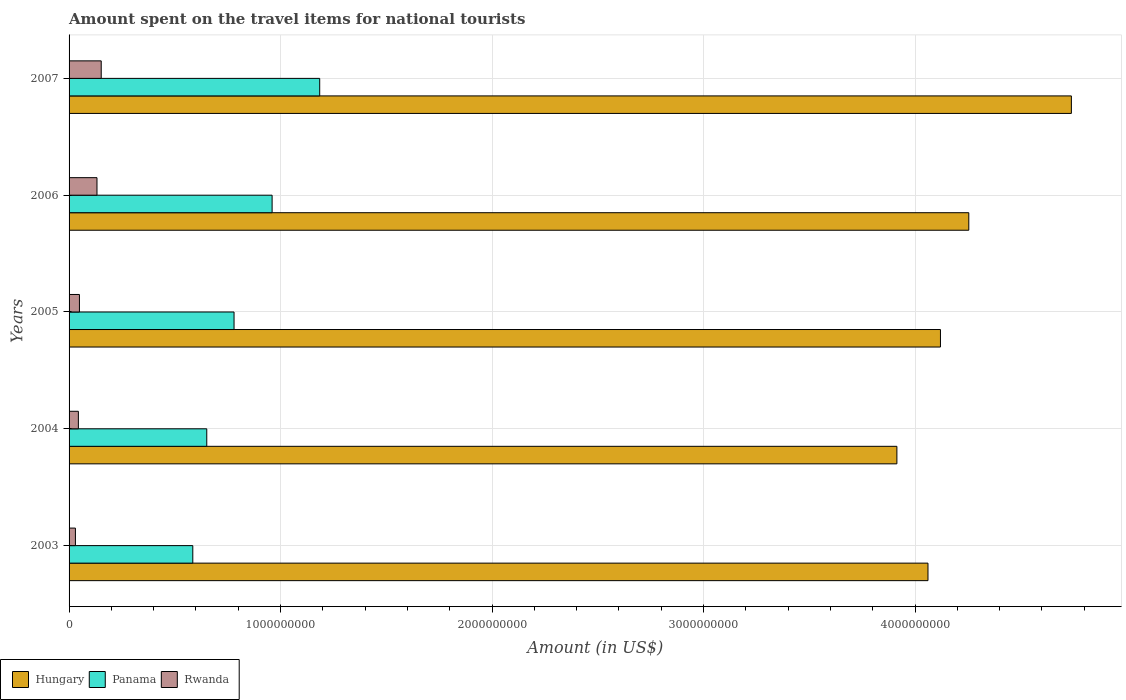How many different coloured bars are there?
Your response must be concise. 3. How many bars are there on the 4th tick from the top?
Your answer should be compact. 3. What is the label of the 3rd group of bars from the top?
Provide a succinct answer. 2005. In how many cases, is the number of bars for a given year not equal to the number of legend labels?
Ensure brevity in your answer.  0. What is the amount spent on the travel items for national tourists in Panama in 2003?
Your answer should be very brief. 5.85e+08. Across all years, what is the maximum amount spent on the travel items for national tourists in Rwanda?
Offer a very short reply. 1.52e+08. Across all years, what is the minimum amount spent on the travel items for national tourists in Hungary?
Ensure brevity in your answer.  3.91e+09. What is the total amount spent on the travel items for national tourists in Panama in the graph?
Your answer should be very brief. 4.16e+09. What is the difference between the amount spent on the travel items for national tourists in Panama in 2003 and that in 2006?
Your response must be concise. -3.75e+08. What is the difference between the amount spent on the travel items for national tourists in Rwanda in 2007 and the amount spent on the travel items for national tourists in Panama in 2003?
Make the answer very short. -4.33e+08. What is the average amount spent on the travel items for national tourists in Rwanda per year?
Offer a very short reply. 8.14e+07. In the year 2003, what is the difference between the amount spent on the travel items for national tourists in Rwanda and amount spent on the travel items for national tourists in Panama?
Make the answer very short. -5.55e+08. What is the ratio of the amount spent on the travel items for national tourists in Hungary in 2004 to that in 2007?
Offer a very short reply. 0.83. Is the amount spent on the travel items for national tourists in Hungary in 2005 less than that in 2006?
Your response must be concise. Yes. What is the difference between the highest and the second highest amount spent on the travel items for national tourists in Hungary?
Your answer should be compact. 4.85e+08. What is the difference between the highest and the lowest amount spent on the travel items for national tourists in Hungary?
Keep it short and to the point. 8.25e+08. What does the 3rd bar from the top in 2004 represents?
Offer a terse response. Hungary. What does the 1st bar from the bottom in 2006 represents?
Your response must be concise. Hungary. Does the graph contain grids?
Ensure brevity in your answer.  Yes. How many legend labels are there?
Ensure brevity in your answer.  3. How are the legend labels stacked?
Provide a short and direct response. Horizontal. What is the title of the graph?
Provide a succinct answer. Amount spent on the travel items for national tourists. Does "Latvia" appear as one of the legend labels in the graph?
Keep it short and to the point. No. What is the label or title of the X-axis?
Your response must be concise. Amount (in US$). What is the label or title of the Y-axis?
Ensure brevity in your answer.  Years. What is the Amount (in US$) in Hungary in 2003?
Your answer should be very brief. 4.06e+09. What is the Amount (in US$) in Panama in 2003?
Your answer should be very brief. 5.85e+08. What is the Amount (in US$) in Rwanda in 2003?
Your response must be concise. 3.00e+07. What is the Amount (in US$) of Hungary in 2004?
Offer a very short reply. 3.91e+09. What is the Amount (in US$) of Panama in 2004?
Offer a very short reply. 6.51e+08. What is the Amount (in US$) in Rwanda in 2004?
Offer a terse response. 4.40e+07. What is the Amount (in US$) in Hungary in 2005?
Your answer should be very brief. 4.12e+09. What is the Amount (in US$) in Panama in 2005?
Keep it short and to the point. 7.80e+08. What is the Amount (in US$) of Rwanda in 2005?
Your answer should be compact. 4.90e+07. What is the Amount (in US$) in Hungary in 2006?
Offer a terse response. 4.25e+09. What is the Amount (in US$) in Panama in 2006?
Offer a terse response. 9.60e+08. What is the Amount (in US$) in Rwanda in 2006?
Offer a very short reply. 1.32e+08. What is the Amount (in US$) in Hungary in 2007?
Provide a short and direct response. 4.74e+09. What is the Amount (in US$) in Panama in 2007?
Ensure brevity in your answer.  1.18e+09. What is the Amount (in US$) of Rwanda in 2007?
Your response must be concise. 1.52e+08. Across all years, what is the maximum Amount (in US$) in Hungary?
Your answer should be very brief. 4.74e+09. Across all years, what is the maximum Amount (in US$) in Panama?
Keep it short and to the point. 1.18e+09. Across all years, what is the maximum Amount (in US$) in Rwanda?
Ensure brevity in your answer.  1.52e+08. Across all years, what is the minimum Amount (in US$) in Hungary?
Ensure brevity in your answer.  3.91e+09. Across all years, what is the minimum Amount (in US$) of Panama?
Provide a short and direct response. 5.85e+08. Across all years, what is the minimum Amount (in US$) in Rwanda?
Your answer should be very brief. 3.00e+07. What is the total Amount (in US$) of Hungary in the graph?
Make the answer very short. 2.11e+1. What is the total Amount (in US$) of Panama in the graph?
Ensure brevity in your answer.  4.16e+09. What is the total Amount (in US$) of Rwanda in the graph?
Your response must be concise. 4.07e+08. What is the difference between the Amount (in US$) in Hungary in 2003 and that in 2004?
Ensure brevity in your answer.  1.47e+08. What is the difference between the Amount (in US$) in Panama in 2003 and that in 2004?
Your response must be concise. -6.60e+07. What is the difference between the Amount (in US$) in Rwanda in 2003 and that in 2004?
Your response must be concise. -1.40e+07. What is the difference between the Amount (in US$) in Hungary in 2003 and that in 2005?
Offer a terse response. -5.90e+07. What is the difference between the Amount (in US$) in Panama in 2003 and that in 2005?
Make the answer very short. -1.95e+08. What is the difference between the Amount (in US$) in Rwanda in 2003 and that in 2005?
Offer a very short reply. -1.90e+07. What is the difference between the Amount (in US$) in Hungary in 2003 and that in 2006?
Provide a succinct answer. -1.93e+08. What is the difference between the Amount (in US$) in Panama in 2003 and that in 2006?
Your response must be concise. -3.75e+08. What is the difference between the Amount (in US$) in Rwanda in 2003 and that in 2006?
Your answer should be very brief. -1.02e+08. What is the difference between the Amount (in US$) in Hungary in 2003 and that in 2007?
Keep it short and to the point. -6.78e+08. What is the difference between the Amount (in US$) in Panama in 2003 and that in 2007?
Keep it short and to the point. -6.00e+08. What is the difference between the Amount (in US$) of Rwanda in 2003 and that in 2007?
Give a very brief answer. -1.22e+08. What is the difference between the Amount (in US$) in Hungary in 2004 and that in 2005?
Offer a terse response. -2.06e+08. What is the difference between the Amount (in US$) in Panama in 2004 and that in 2005?
Make the answer very short. -1.29e+08. What is the difference between the Amount (in US$) of Rwanda in 2004 and that in 2005?
Your answer should be very brief. -5.00e+06. What is the difference between the Amount (in US$) in Hungary in 2004 and that in 2006?
Keep it short and to the point. -3.40e+08. What is the difference between the Amount (in US$) in Panama in 2004 and that in 2006?
Offer a very short reply. -3.09e+08. What is the difference between the Amount (in US$) in Rwanda in 2004 and that in 2006?
Provide a short and direct response. -8.80e+07. What is the difference between the Amount (in US$) of Hungary in 2004 and that in 2007?
Give a very brief answer. -8.25e+08. What is the difference between the Amount (in US$) of Panama in 2004 and that in 2007?
Provide a short and direct response. -5.34e+08. What is the difference between the Amount (in US$) in Rwanda in 2004 and that in 2007?
Provide a short and direct response. -1.08e+08. What is the difference between the Amount (in US$) in Hungary in 2005 and that in 2006?
Your response must be concise. -1.34e+08. What is the difference between the Amount (in US$) in Panama in 2005 and that in 2006?
Your response must be concise. -1.80e+08. What is the difference between the Amount (in US$) of Rwanda in 2005 and that in 2006?
Make the answer very short. -8.30e+07. What is the difference between the Amount (in US$) in Hungary in 2005 and that in 2007?
Your answer should be compact. -6.19e+08. What is the difference between the Amount (in US$) in Panama in 2005 and that in 2007?
Provide a succinct answer. -4.05e+08. What is the difference between the Amount (in US$) of Rwanda in 2005 and that in 2007?
Offer a terse response. -1.03e+08. What is the difference between the Amount (in US$) in Hungary in 2006 and that in 2007?
Provide a short and direct response. -4.85e+08. What is the difference between the Amount (in US$) of Panama in 2006 and that in 2007?
Make the answer very short. -2.25e+08. What is the difference between the Amount (in US$) in Rwanda in 2006 and that in 2007?
Your answer should be very brief. -2.00e+07. What is the difference between the Amount (in US$) in Hungary in 2003 and the Amount (in US$) in Panama in 2004?
Make the answer very short. 3.41e+09. What is the difference between the Amount (in US$) in Hungary in 2003 and the Amount (in US$) in Rwanda in 2004?
Offer a very short reply. 4.02e+09. What is the difference between the Amount (in US$) in Panama in 2003 and the Amount (in US$) in Rwanda in 2004?
Offer a very short reply. 5.41e+08. What is the difference between the Amount (in US$) in Hungary in 2003 and the Amount (in US$) in Panama in 2005?
Your response must be concise. 3.28e+09. What is the difference between the Amount (in US$) in Hungary in 2003 and the Amount (in US$) in Rwanda in 2005?
Offer a terse response. 4.01e+09. What is the difference between the Amount (in US$) of Panama in 2003 and the Amount (in US$) of Rwanda in 2005?
Your answer should be very brief. 5.36e+08. What is the difference between the Amount (in US$) in Hungary in 2003 and the Amount (in US$) in Panama in 2006?
Your answer should be compact. 3.10e+09. What is the difference between the Amount (in US$) of Hungary in 2003 and the Amount (in US$) of Rwanda in 2006?
Your answer should be very brief. 3.93e+09. What is the difference between the Amount (in US$) of Panama in 2003 and the Amount (in US$) of Rwanda in 2006?
Ensure brevity in your answer.  4.53e+08. What is the difference between the Amount (in US$) in Hungary in 2003 and the Amount (in US$) in Panama in 2007?
Ensure brevity in your answer.  2.88e+09. What is the difference between the Amount (in US$) of Hungary in 2003 and the Amount (in US$) of Rwanda in 2007?
Your response must be concise. 3.91e+09. What is the difference between the Amount (in US$) of Panama in 2003 and the Amount (in US$) of Rwanda in 2007?
Give a very brief answer. 4.33e+08. What is the difference between the Amount (in US$) of Hungary in 2004 and the Amount (in US$) of Panama in 2005?
Provide a succinct answer. 3.13e+09. What is the difference between the Amount (in US$) in Hungary in 2004 and the Amount (in US$) in Rwanda in 2005?
Make the answer very short. 3.86e+09. What is the difference between the Amount (in US$) of Panama in 2004 and the Amount (in US$) of Rwanda in 2005?
Your answer should be very brief. 6.02e+08. What is the difference between the Amount (in US$) in Hungary in 2004 and the Amount (in US$) in Panama in 2006?
Make the answer very short. 2.95e+09. What is the difference between the Amount (in US$) of Hungary in 2004 and the Amount (in US$) of Rwanda in 2006?
Provide a succinct answer. 3.78e+09. What is the difference between the Amount (in US$) in Panama in 2004 and the Amount (in US$) in Rwanda in 2006?
Offer a terse response. 5.19e+08. What is the difference between the Amount (in US$) of Hungary in 2004 and the Amount (in US$) of Panama in 2007?
Provide a succinct answer. 2.73e+09. What is the difference between the Amount (in US$) of Hungary in 2004 and the Amount (in US$) of Rwanda in 2007?
Your response must be concise. 3.76e+09. What is the difference between the Amount (in US$) of Panama in 2004 and the Amount (in US$) of Rwanda in 2007?
Ensure brevity in your answer.  4.99e+08. What is the difference between the Amount (in US$) in Hungary in 2005 and the Amount (in US$) in Panama in 2006?
Provide a short and direct response. 3.16e+09. What is the difference between the Amount (in US$) of Hungary in 2005 and the Amount (in US$) of Rwanda in 2006?
Make the answer very short. 3.99e+09. What is the difference between the Amount (in US$) in Panama in 2005 and the Amount (in US$) in Rwanda in 2006?
Offer a terse response. 6.48e+08. What is the difference between the Amount (in US$) of Hungary in 2005 and the Amount (in US$) of Panama in 2007?
Your response must be concise. 2.94e+09. What is the difference between the Amount (in US$) in Hungary in 2005 and the Amount (in US$) in Rwanda in 2007?
Provide a short and direct response. 3.97e+09. What is the difference between the Amount (in US$) in Panama in 2005 and the Amount (in US$) in Rwanda in 2007?
Provide a short and direct response. 6.28e+08. What is the difference between the Amount (in US$) in Hungary in 2006 and the Amount (in US$) in Panama in 2007?
Offer a very short reply. 3.07e+09. What is the difference between the Amount (in US$) of Hungary in 2006 and the Amount (in US$) of Rwanda in 2007?
Ensure brevity in your answer.  4.10e+09. What is the difference between the Amount (in US$) of Panama in 2006 and the Amount (in US$) of Rwanda in 2007?
Make the answer very short. 8.08e+08. What is the average Amount (in US$) of Hungary per year?
Your response must be concise. 4.22e+09. What is the average Amount (in US$) in Panama per year?
Make the answer very short. 8.32e+08. What is the average Amount (in US$) of Rwanda per year?
Keep it short and to the point. 8.14e+07. In the year 2003, what is the difference between the Amount (in US$) in Hungary and Amount (in US$) in Panama?
Provide a short and direct response. 3.48e+09. In the year 2003, what is the difference between the Amount (in US$) of Hungary and Amount (in US$) of Rwanda?
Offer a very short reply. 4.03e+09. In the year 2003, what is the difference between the Amount (in US$) in Panama and Amount (in US$) in Rwanda?
Offer a very short reply. 5.55e+08. In the year 2004, what is the difference between the Amount (in US$) in Hungary and Amount (in US$) in Panama?
Ensure brevity in your answer.  3.26e+09. In the year 2004, what is the difference between the Amount (in US$) of Hungary and Amount (in US$) of Rwanda?
Offer a terse response. 3.87e+09. In the year 2004, what is the difference between the Amount (in US$) in Panama and Amount (in US$) in Rwanda?
Make the answer very short. 6.07e+08. In the year 2005, what is the difference between the Amount (in US$) in Hungary and Amount (in US$) in Panama?
Your answer should be very brief. 3.34e+09. In the year 2005, what is the difference between the Amount (in US$) of Hungary and Amount (in US$) of Rwanda?
Your answer should be compact. 4.07e+09. In the year 2005, what is the difference between the Amount (in US$) of Panama and Amount (in US$) of Rwanda?
Ensure brevity in your answer.  7.31e+08. In the year 2006, what is the difference between the Amount (in US$) in Hungary and Amount (in US$) in Panama?
Provide a short and direct response. 3.29e+09. In the year 2006, what is the difference between the Amount (in US$) of Hungary and Amount (in US$) of Rwanda?
Provide a short and direct response. 4.12e+09. In the year 2006, what is the difference between the Amount (in US$) of Panama and Amount (in US$) of Rwanda?
Provide a succinct answer. 8.28e+08. In the year 2007, what is the difference between the Amount (in US$) in Hungary and Amount (in US$) in Panama?
Keep it short and to the point. 3.55e+09. In the year 2007, what is the difference between the Amount (in US$) of Hungary and Amount (in US$) of Rwanda?
Provide a succinct answer. 4.59e+09. In the year 2007, what is the difference between the Amount (in US$) of Panama and Amount (in US$) of Rwanda?
Your answer should be very brief. 1.03e+09. What is the ratio of the Amount (in US$) of Hungary in 2003 to that in 2004?
Provide a succinct answer. 1.04. What is the ratio of the Amount (in US$) of Panama in 2003 to that in 2004?
Your answer should be compact. 0.9. What is the ratio of the Amount (in US$) in Rwanda in 2003 to that in 2004?
Provide a short and direct response. 0.68. What is the ratio of the Amount (in US$) of Hungary in 2003 to that in 2005?
Ensure brevity in your answer.  0.99. What is the ratio of the Amount (in US$) of Rwanda in 2003 to that in 2005?
Your response must be concise. 0.61. What is the ratio of the Amount (in US$) of Hungary in 2003 to that in 2006?
Offer a terse response. 0.95. What is the ratio of the Amount (in US$) in Panama in 2003 to that in 2006?
Provide a succinct answer. 0.61. What is the ratio of the Amount (in US$) in Rwanda in 2003 to that in 2006?
Your response must be concise. 0.23. What is the ratio of the Amount (in US$) in Hungary in 2003 to that in 2007?
Make the answer very short. 0.86. What is the ratio of the Amount (in US$) of Panama in 2003 to that in 2007?
Offer a very short reply. 0.49. What is the ratio of the Amount (in US$) of Rwanda in 2003 to that in 2007?
Offer a very short reply. 0.2. What is the ratio of the Amount (in US$) in Panama in 2004 to that in 2005?
Your answer should be very brief. 0.83. What is the ratio of the Amount (in US$) of Rwanda in 2004 to that in 2005?
Ensure brevity in your answer.  0.9. What is the ratio of the Amount (in US$) in Hungary in 2004 to that in 2006?
Give a very brief answer. 0.92. What is the ratio of the Amount (in US$) of Panama in 2004 to that in 2006?
Provide a short and direct response. 0.68. What is the ratio of the Amount (in US$) of Rwanda in 2004 to that in 2006?
Your response must be concise. 0.33. What is the ratio of the Amount (in US$) in Hungary in 2004 to that in 2007?
Provide a short and direct response. 0.83. What is the ratio of the Amount (in US$) of Panama in 2004 to that in 2007?
Give a very brief answer. 0.55. What is the ratio of the Amount (in US$) of Rwanda in 2004 to that in 2007?
Offer a terse response. 0.29. What is the ratio of the Amount (in US$) of Hungary in 2005 to that in 2006?
Provide a short and direct response. 0.97. What is the ratio of the Amount (in US$) of Panama in 2005 to that in 2006?
Provide a short and direct response. 0.81. What is the ratio of the Amount (in US$) in Rwanda in 2005 to that in 2006?
Your response must be concise. 0.37. What is the ratio of the Amount (in US$) in Hungary in 2005 to that in 2007?
Offer a terse response. 0.87. What is the ratio of the Amount (in US$) in Panama in 2005 to that in 2007?
Your answer should be very brief. 0.66. What is the ratio of the Amount (in US$) in Rwanda in 2005 to that in 2007?
Provide a succinct answer. 0.32. What is the ratio of the Amount (in US$) in Hungary in 2006 to that in 2007?
Your answer should be very brief. 0.9. What is the ratio of the Amount (in US$) in Panama in 2006 to that in 2007?
Keep it short and to the point. 0.81. What is the ratio of the Amount (in US$) in Rwanda in 2006 to that in 2007?
Offer a very short reply. 0.87. What is the difference between the highest and the second highest Amount (in US$) of Hungary?
Provide a short and direct response. 4.85e+08. What is the difference between the highest and the second highest Amount (in US$) in Panama?
Offer a very short reply. 2.25e+08. What is the difference between the highest and the second highest Amount (in US$) of Rwanda?
Your response must be concise. 2.00e+07. What is the difference between the highest and the lowest Amount (in US$) of Hungary?
Give a very brief answer. 8.25e+08. What is the difference between the highest and the lowest Amount (in US$) of Panama?
Keep it short and to the point. 6.00e+08. What is the difference between the highest and the lowest Amount (in US$) in Rwanda?
Your response must be concise. 1.22e+08. 